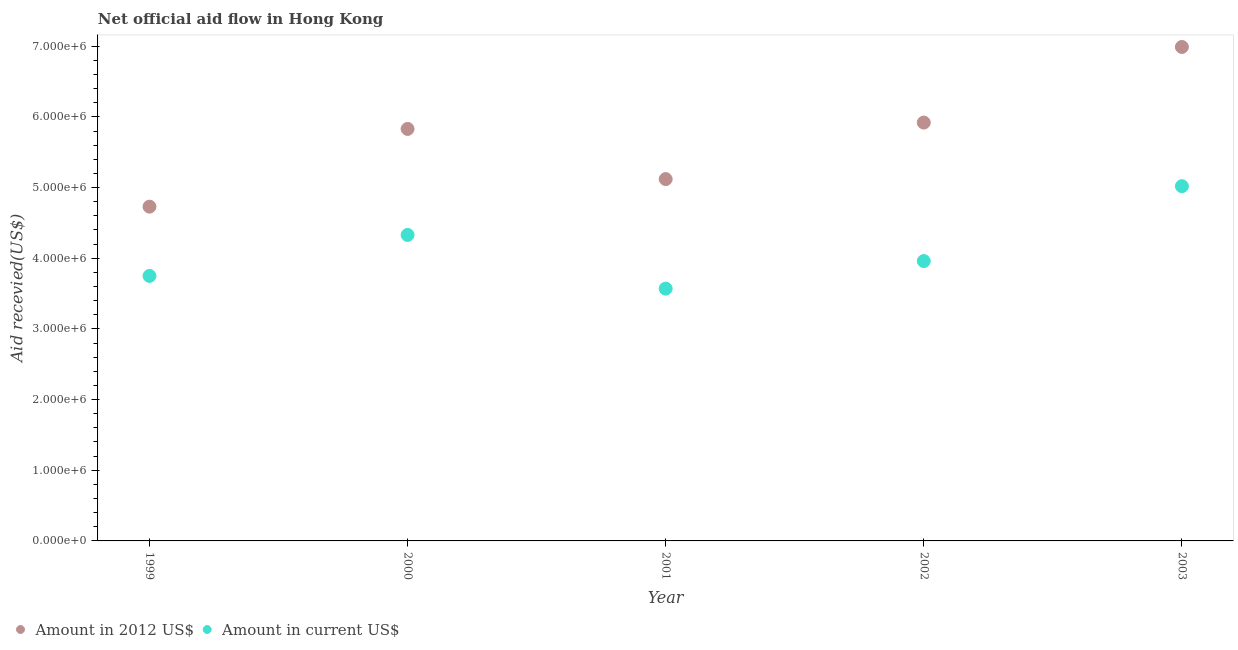How many different coloured dotlines are there?
Offer a terse response. 2. What is the amount of aid received(expressed in 2012 us$) in 2003?
Keep it short and to the point. 6.99e+06. Across all years, what is the maximum amount of aid received(expressed in us$)?
Provide a succinct answer. 5.02e+06. Across all years, what is the minimum amount of aid received(expressed in us$)?
Offer a terse response. 3.57e+06. In which year was the amount of aid received(expressed in 2012 us$) maximum?
Your answer should be compact. 2003. What is the total amount of aid received(expressed in 2012 us$) in the graph?
Offer a terse response. 2.86e+07. What is the difference between the amount of aid received(expressed in 2012 us$) in 1999 and that in 2002?
Offer a very short reply. -1.19e+06. What is the difference between the amount of aid received(expressed in us$) in 2002 and the amount of aid received(expressed in 2012 us$) in 2000?
Your response must be concise. -1.87e+06. What is the average amount of aid received(expressed in 2012 us$) per year?
Keep it short and to the point. 5.72e+06. In the year 2002, what is the difference between the amount of aid received(expressed in 2012 us$) and amount of aid received(expressed in us$)?
Make the answer very short. 1.96e+06. In how many years, is the amount of aid received(expressed in 2012 us$) greater than 400000 US$?
Your response must be concise. 5. What is the ratio of the amount of aid received(expressed in us$) in 1999 to that in 2000?
Give a very brief answer. 0.87. Is the amount of aid received(expressed in 2012 us$) in 2002 less than that in 2003?
Offer a very short reply. Yes. What is the difference between the highest and the second highest amount of aid received(expressed in us$)?
Give a very brief answer. 6.90e+05. What is the difference between the highest and the lowest amount of aid received(expressed in 2012 us$)?
Your answer should be very brief. 2.26e+06. Does the amount of aid received(expressed in 2012 us$) monotonically increase over the years?
Keep it short and to the point. No. Is the amount of aid received(expressed in us$) strictly greater than the amount of aid received(expressed in 2012 us$) over the years?
Keep it short and to the point. No. Is the amount of aid received(expressed in us$) strictly less than the amount of aid received(expressed in 2012 us$) over the years?
Your answer should be very brief. Yes. Does the graph contain any zero values?
Your answer should be compact. No. Where does the legend appear in the graph?
Offer a very short reply. Bottom left. What is the title of the graph?
Provide a succinct answer. Net official aid flow in Hong Kong. Does "Measles" appear as one of the legend labels in the graph?
Make the answer very short. No. What is the label or title of the Y-axis?
Offer a terse response. Aid recevied(US$). What is the Aid recevied(US$) in Amount in 2012 US$ in 1999?
Keep it short and to the point. 4.73e+06. What is the Aid recevied(US$) in Amount in current US$ in 1999?
Keep it short and to the point. 3.75e+06. What is the Aid recevied(US$) in Amount in 2012 US$ in 2000?
Give a very brief answer. 5.83e+06. What is the Aid recevied(US$) in Amount in current US$ in 2000?
Provide a short and direct response. 4.33e+06. What is the Aid recevied(US$) of Amount in 2012 US$ in 2001?
Give a very brief answer. 5.12e+06. What is the Aid recevied(US$) of Amount in current US$ in 2001?
Offer a terse response. 3.57e+06. What is the Aid recevied(US$) in Amount in 2012 US$ in 2002?
Make the answer very short. 5.92e+06. What is the Aid recevied(US$) of Amount in current US$ in 2002?
Your response must be concise. 3.96e+06. What is the Aid recevied(US$) of Amount in 2012 US$ in 2003?
Provide a short and direct response. 6.99e+06. What is the Aid recevied(US$) of Amount in current US$ in 2003?
Give a very brief answer. 5.02e+06. Across all years, what is the maximum Aid recevied(US$) of Amount in 2012 US$?
Provide a succinct answer. 6.99e+06. Across all years, what is the maximum Aid recevied(US$) in Amount in current US$?
Offer a terse response. 5.02e+06. Across all years, what is the minimum Aid recevied(US$) of Amount in 2012 US$?
Your answer should be compact. 4.73e+06. Across all years, what is the minimum Aid recevied(US$) in Amount in current US$?
Your answer should be very brief. 3.57e+06. What is the total Aid recevied(US$) in Amount in 2012 US$ in the graph?
Keep it short and to the point. 2.86e+07. What is the total Aid recevied(US$) in Amount in current US$ in the graph?
Provide a short and direct response. 2.06e+07. What is the difference between the Aid recevied(US$) in Amount in 2012 US$ in 1999 and that in 2000?
Ensure brevity in your answer.  -1.10e+06. What is the difference between the Aid recevied(US$) of Amount in current US$ in 1999 and that in 2000?
Ensure brevity in your answer.  -5.80e+05. What is the difference between the Aid recevied(US$) in Amount in 2012 US$ in 1999 and that in 2001?
Your response must be concise. -3.90e+05. What is the difference between the Aid recevied(US$) of Amount in current US$ in 1999 and that in 2001?
Your answer should be very brief. 1.80e+05. What is the difference between the Aid recevied(US$) in Amount in 2012 US$ in 1999 and that in 2002?
Offer a very short reply. -1.19e+06. What is the difference between the Aid recevied(US$) of Amount in current US$ in 1999 and that in 2002?
Provide a succinct answer. -2.10e+05. What is the difference between the Aid recevied(US$) of Amount in 2012 US$ in 1999 and that in 2003?
Ensure brevity in your answer.  -2.26e+06. What is the difference between the Aid recevied(US$) of Amount in current US$ in 1999 and that in 2003?
Ensure brevity in your answer.  -1.27e+06. What is the difference between the Aid recevied(US$) in Amount in 2012 US$ in 2000 and that in 2001?
Offer a terse response. 7.10e+05. What is the difference between the Aid recevied(US$) of Amount in current US$ in 2000 and that in 2001?
Make the answer very short. 7.60e+05. What is the difference between the Aid recevied(US$) in Amount in 2012 US$ in 2000 and that in 2002?
Your answer should be compact. -9.00e+04. What is the difference between the Aid recevied(US$) in Amount in current US$ in 2000 and that in 2002?
Give a very brief answer. 3.70e+05. What is the difference between the Aid recevied(US$) in Amount in 2012 US$ in 2000 and that in 2003?
Your answer should be very brief. -1.16e+06. What is the difference between the Aid recevied(US$) of Amount in current US$ in 2000 and that in 2003?
Your response must be concise. -6.90e+05. What is the difference between the Aid recevied(US$) in Amount in 2012 US$ in 2001 and that in 2002?
Your answer should be very brief. -8.00e+05. What is the difference between the Aid recevied(US$) of Amount in current US$ in 2001 and that in 2002?
Ensure brevity in your answer.  -3.90e+05. What is the difference between the Aid recevied(US$) of Amount in 2012 US$ in 2001 and that in 2003?
Your answer should be very brief. -1.87e+06. What is the difference between the Aid recevied(US$) in Amount in current US$ in 2001 and that in 2003?
Ensure brevity in your answer.  -1.45e+06. What is the difference between the Aid recevied(US$) of Amount in 2012 US$ in 2002 and that in 2003?
Offer a very short reply. -1.07e+06. What is the difference between the Aid recevied(US$) in Amount in current US$ in 2002 and that in 2003?
Offer a terse response. -1.06e+06. What is the difference between the Aid recevied(US$) of Amount in 2012 US$ in 1999 and the Aid recevied(US$) of Amount in current US$ in 2000?
Keep it short and to the point. 4.00e+05. What is the difference between the Aid recevied(US$) of Amount in 2012 US$ in 1999 and the Aid recevied(US$) of Amount in current US$ in 2001?
Your response must be concise. 1.16e+06. What is the difference between the Aid recevied(US$) in Amount in 2012 US$ in 1999 and the Aid recevied(US$) in Amount in current US$ in 2002?
Keep it short and to the point. 7.70e+05. What is the difference between the Aid recevied(US$) of Amount in 2012 US$ in 2000 and the Aid recevied(US$) of Amount in current US$ in 2001?
Offer a very short reply. 2.26e+06. What is the difference between the Aid recevied(US$) in Amount in 2012 US$ in 2000 and the Aid recevied(US$) in Amount in current US$ in 2002?
Provide a succinct answer. 1.87e+06. What is the difference between the Aid recevied(US$) in Amount in 2012 US$ in 2000 and the Aid recevied(US$) in Amount in current US$ in 2003?
Provide a succinct answer. 8.10e+05. What is the difference between the Aid recevied(US$) of Amount in 2012 US$ in 2001 and the Aid recevied(US$) of Amount in current US$ in 2002?
Keep it short and to the point. 1.16e+06. What is the difference between the Aid recevied(US$) in Amount in 2012 US$ in 2001 and the Aid recevied(US$) in Amount in current US$ in 2003?
Offer a very short reply. 1.00e+05. What is the difference between the Aid recevied(US$) in Amount in 2012 US$ in 2002 and the Aid recevied(US$) in Amount in current US$ in 2003?
Provide a short and direct response. 9.00e+05. What is the average Aid recevied(US$) in Amount in 2012 US$ per year?
Provide a succinct answer. 5.72e+06. What is the average Aid recevied(US$) of Amount in current US$ per year?
Provide a succinct answer. 4.13e+06. In the year 1999, what is the difference between the Aid recevied(US$) of Amount in 2012 US$ and Aid recevied(US$) of Amount in current US$?
Your response must be concise. 9.80e+05. In the year 2000, what is the difference between the Aid recevied(US$) of Amount in 2012 US$ and Aid recevied(US$) of Amount in current US$?
Provide a succinct answer. 1.50e+06. In the year 2001, what is the difference between the Aid recevied(US$) of Amount in 2012 US$ and Aid recevied(US$) of Amount in current US$?
Offer a very short reply. 1.55e+06. In the year 2002, what is the difference between the Aid recevied(US$) in Amount in 2012 US$ and Aid recevied(US$) in Amount in current US$?
Your answer should be compact. 1.96e+06. In the year 2003, what is the difference between the Aid recevied(US$) of Amount in 2012 US$ and Aid recevied(US$) of Amount in current US$?
Offer a terse response. 1.97e+06. What is the ratio of the Aid recevied(US$) of Amount in 2012 US$ in 1999 to that in 2000?
Give a very brief answer. 0.81. What is the ratio of the Aid recevied(US$) of Amount in current US$ in 1999 to that in 2000?
Keep it short and to the point. 0.87. What is the ratio of the Aid recevied(US$) of Amount in 2012 US$ in 1999 to that in 2001?
Offer a terse response. 0.92. What is the ratio of the Aid recevied(US$) of Amount in current US$ in 1999 to that in 2001?
Your answer should be compact. 1.05. What is the ratio of the Aid recevied(US$) in Amount in 2012 US$ in 1999 to that in 2002?
Ensure brevity in your answer.  0.8. What is the ratio of the Aid recevied(US$) in Amount in current US$ in 1999 to that in 2002?
Make the answer very short. 0.95. What is the ratio of the Aid recevied(US$) of Amount in 2012 US$ in 1999 to that in 2003?
Provide a short and direct response. 0.68. What is the ratio of the Aid recevied(US$) of Amount in current US$ in 1999 to that in 2003?
Give a very brief answer. 0.75. What is the ratio of the Aid recevied(US$) of Amount in 2012 US$ in 2000 to that in 2001?
Provide a succinct answer. 1.14. What is the ratio of the Aid recevied(US$) of Amount in current US$ in 2000 to that in 2001?
Make the answer very short. 1.21. What is the ratio of the Aid recevied(US$) in Amount in current US$ in 2000 to that in 2002?
Make the answer very short. 1.09. What is the ratio of the Aid recevied(US$) in Amount in 2012 US$ in 2000 to that in 2003?
Make the answer very short. 0.83. What is the ratio of the Aid recevied(US$) of Amount in current US$ in 2000 to that in 2003?
Your response must be concise. 0.86. What is the ratio of the Aid recevied(US$) in Amount in 2012 US$ in 2001 to that in 2002?
Your answer should be compact. 0.86. What is the ratio of the Aid recevied(US$) of Amount in current US$ in 2001 to that in 2002?
Provide a short and direct response. 0.9. What is the ratio of the Aid recevied(US$) of Amount in 2012 US$ in 2001 to that in 2003?
Make the answer very short. 0.73. What is the ratio of the Aid recevied(US$) in Amount in current US$ in 2001 to that in 2003?
Your answer should be compact. 0.71. What is the ratio of the Aid recevied(US$) of Amount in 2012 US$ in 2002 to that in 2003?
Your answer should be compact. 0.85. What is the ratio of the Aid recevied(US$) in Amount in current US$ in 2002 to that in 2003?
Your answer should be very brief. 0.79. What is the difference between the highest and the second highest Aid recevied(US$) in Amount in 2012 US$?
Ensure brevity in your answer.  1.07e+06. What is the difference between the highest and the second highest Aid recevied(US$) in Amount in current US$?
Offer a terse response. 6.90e+05. What is the difference between the highest and the lowest Aid recevied(US$) of Amount in 2012 US$?
Provide a short and direct response. 2.26e+06. What is the difference between the highest and the lowest Aid recevied(US$) of Amount in current US$?
Your answer should be very brief. 1.45e+06. 